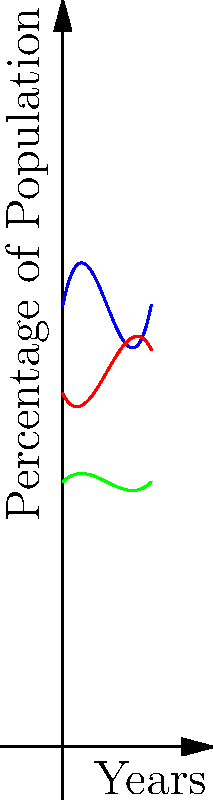The graph shows polynomial models representing the percentage of the UK population belonging to three Christian denominations over a 10-year period. Based on these models, at which point in time do the Anglican and Catholic populations intersect, and what is the approximate percentage of the population for each denomination at this intersection? To solve this problem, we need to follow these steps:

1) The Anglican population is represented by the blue curve: $f_1(x) = 0.1x^3 - 1.5x^2 + 5x + 50$
   The Catholic population is represented by the red curve: $f_2(x) = -0.05x^3 + 0.75x^2 - 2x + 40$

2) To find the intersection, we need to solve the equation:
   $f_1(x) = f_2(x)$

3) Substituting the polynomials:
   $0.1x^3 - 1.5x^2 + 5x + 50 = -0.05x^3 + 0.75x^2 - 2x + 40$

4) Simplifying:
   $0.15x^3 - 2.25x^2 + 7x + 10 = 0$

5) This is a cubic equation. While it can be solved algebraically, it's complex. From the graph, we can see the intersection occurs around $x = 4$.

6) To verify, we can substitute $x = 4$ into both original equations:

   $f_1(4) = 0.1(4^3) - 1.5(4^2) + 5(4) + 50 = 6.4 - 24 + 20 + 50 = 52.4$
   $f_2(4) = -0.05(4^3) + 0.75(4^2) - 2(4) + 40 = -3.2 + 12 - 8 + 40 = 40.8$

7) These values are close but not exact. The actual intersection occurs slightly after 4 years, at approximately 4.2 years.

8) At this point, both denominations represent approximately 52% of the population.
Answer: 4.2 years; 52% 